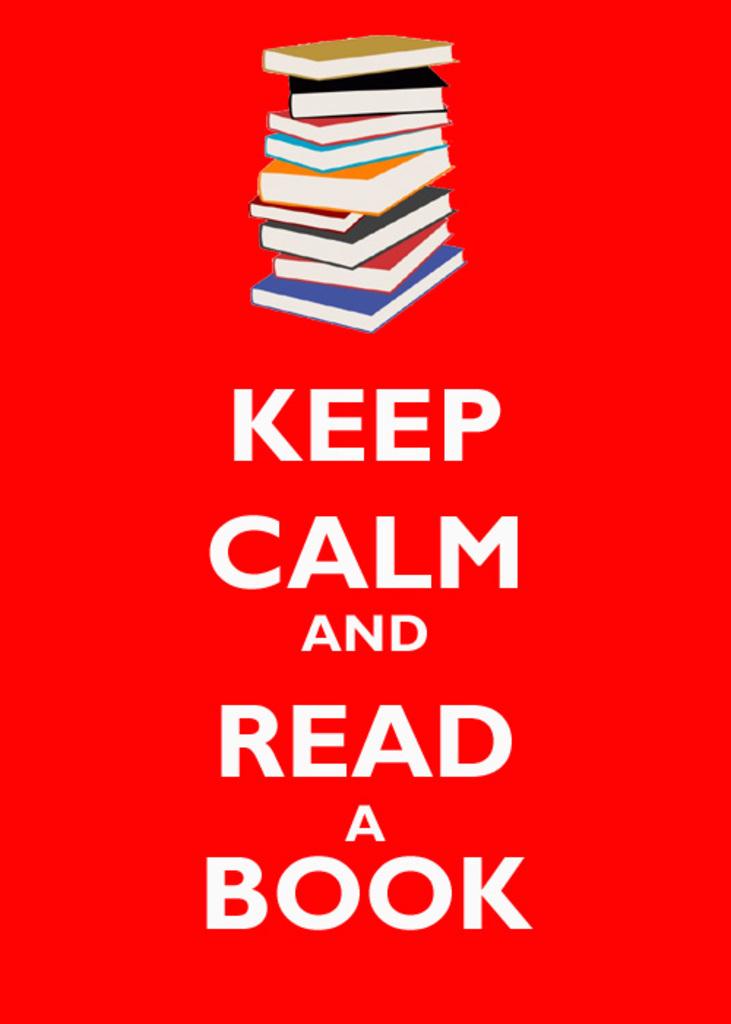What is the first suggestion on this picture?
Your response must be concise. Keep calm. 